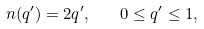<formula> <loc_0><loc_0><loc_500><loc_500>n ( q ^ { \prime } ) = 2 q ^ { \prime } , \quad 0 \leq q ^ { \prime } \leq 1 ,</formula> 